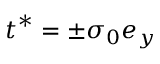<formula> <loc_0><loc_0><loc_500><loc_500>t ^ { * } = \pm { \sigma } _ { 0 } e _ { y }</formula> 